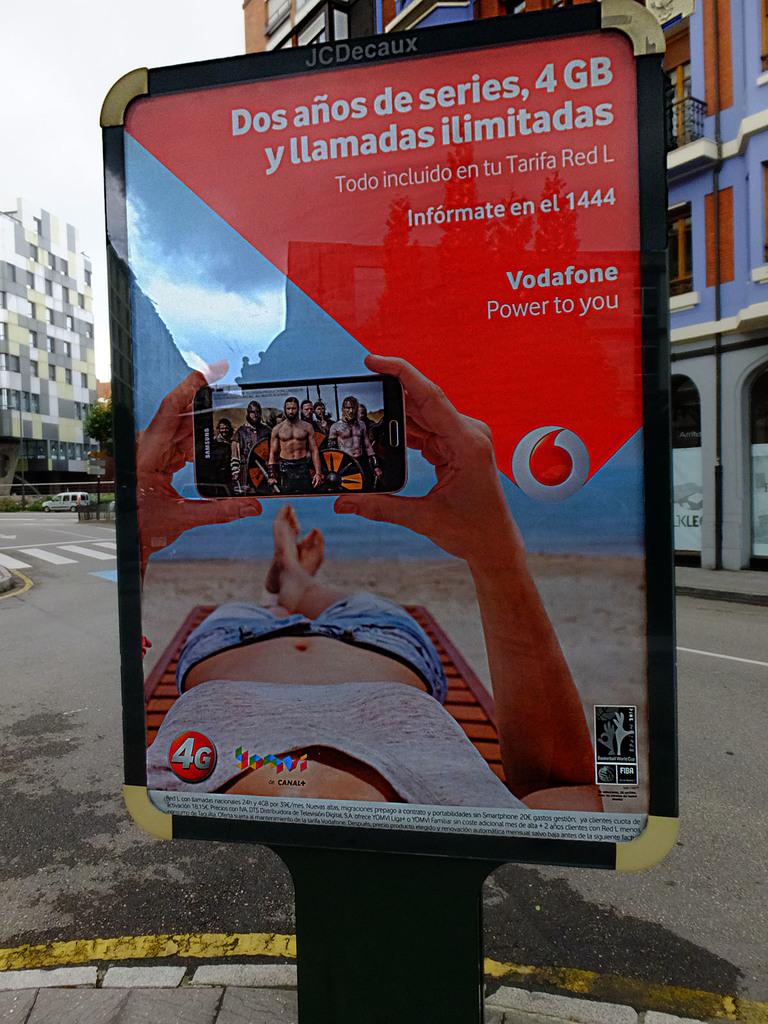What is the ad used for?
Your answer should be very brief. Vodafone. What is vodafone's motto?
Ensure brevity in your answer.  Power to you. 